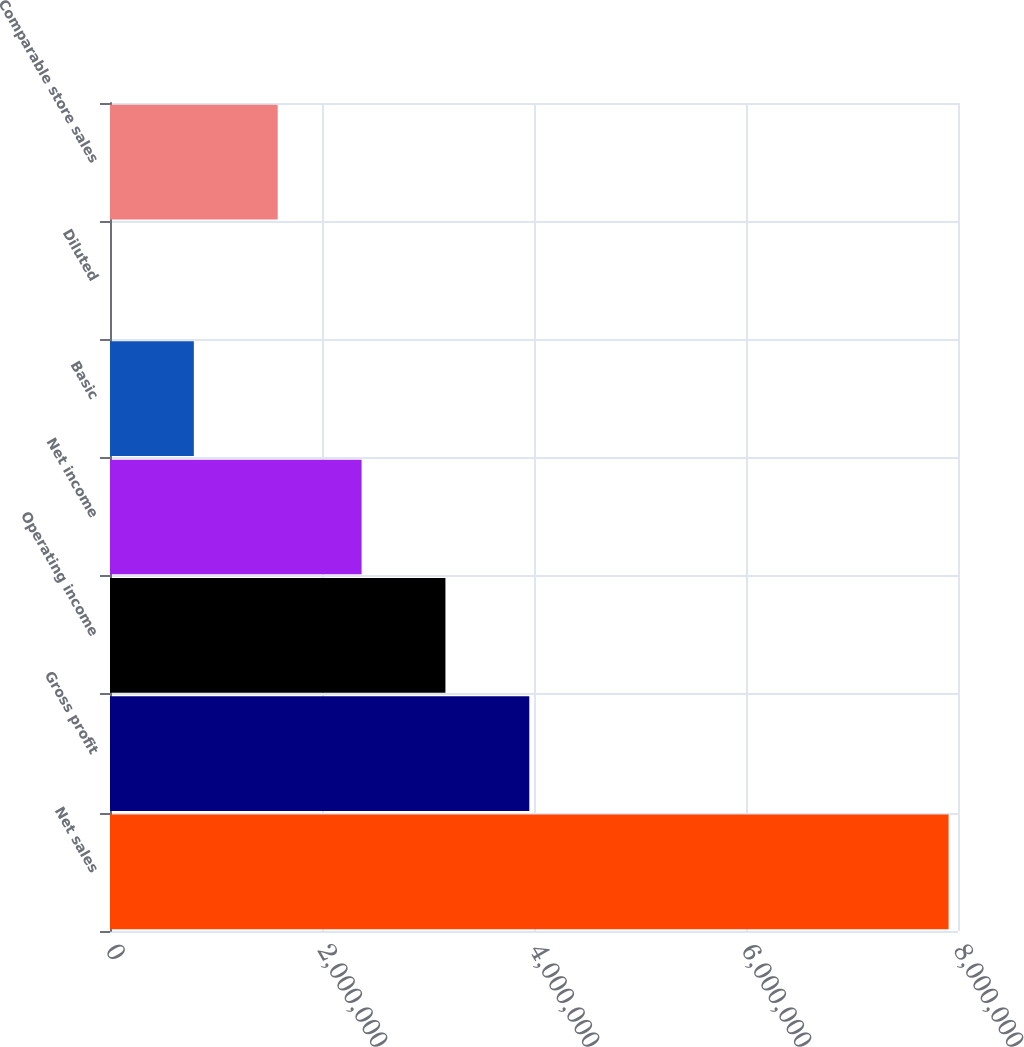Convert chart. <chart><loc_0><loc_0><loc_500><loc_500><bar_chart><fcel>Net sales<fcel>Gross profit<fcel>Operating income<fcel>Net income<fcel>Basic<fcel>Diluted<fcel>Comparable store sales<nl><fcel>7.91105e+06<fcel>3.95553e+06<fcel>3.16442e+06<fcel>2.37332e+06<fcel>791108<fcel>4.31<fcel>1.58221e+06<nl></chart> 